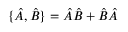Convert formula to latex. <formula><loc_0><loc_0><loc_500><loc_500>\{ \hat { A } , \hat { B } \} = \hat { A } \hat { B } + \hat { B } \hat { A }</formula> 